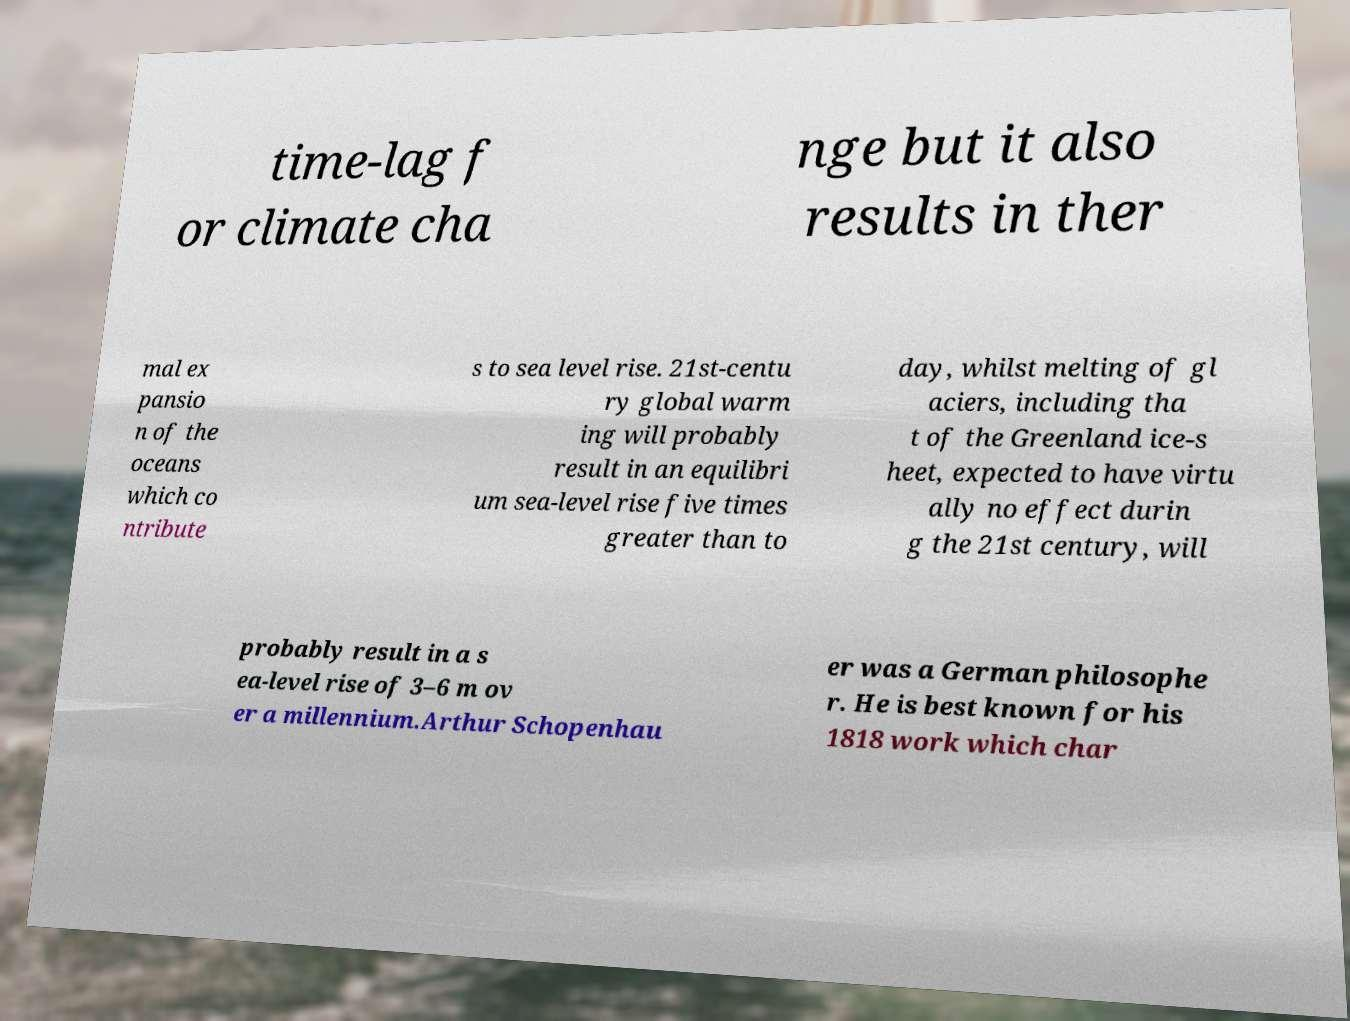Could you extract and type out the text from this image? time-lag f or climate cha nge but it also results in ther mal ex pansio n of the oceans which co ntribute s to sea level rise. 21st-centu ry global warm ing will probably result in an equilibri um sea-level rise five times greater than to day, whilst melting of gl aciers, including tha t of the Greenland ice-s heet, expected to have virtu ally no effect durin g the 21st century, will probably result in a s ea-level rise of 3–6 m ov er a millennium.Arthur Schopenhau er was a German philosophe r. He is best known for his 1818 work which char 